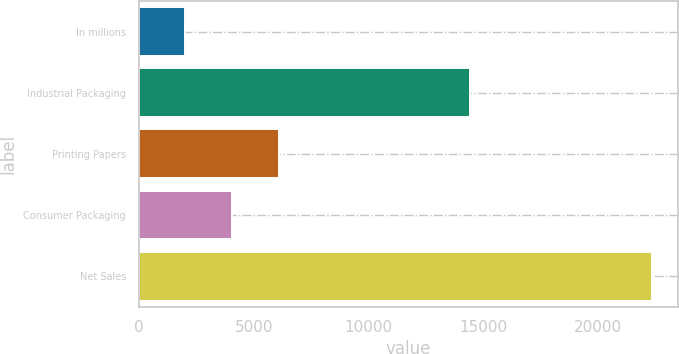<chart> <loc_0><loc_0><loc_500><loc_500><bar_chart><fcel>In millions<fcel>Industrial Packaging<fcel>Printing Papers<fcel>Consumer Packaging<fcel>Net Sales<nl><fcel>2015<fcel>14421<fcel>6085<fcel>4050<fcel>22365<nl></chart> 